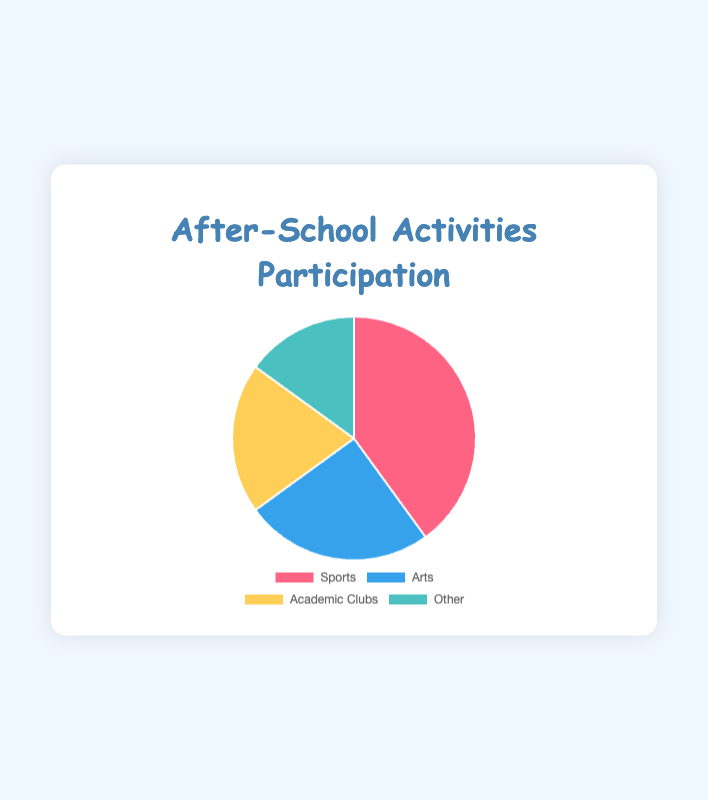Which activity has the highest participation percentage? The pie chart shows the participation percentages for different activities. By looking at the chart, we see that "Sports" has the largest segment.
Answer: Sports Which activity type has the smallest participation percentage? The pie chart segments represent different activity types, each labeled with its percentage. The smallest segment corresponds to "Other," indicating it has the lowest participation.
Answer: Other What is the combined participation percentage for Arts and Academic Clubs? To find the combined percentage, sum up the participation percentages of "Arts" and "Academic Clubs". Arts have 25% and Academic Clubs have 20%. 25% + 20% = 45%
Answer: 45% How much larger is the participation in Sports compared to Other activities? Calculate the difference between the Sports participation percentage (40%) and the Other activities participation percentage (15%). 40% - 15% = 25%
Answer: 25% If you combine the participation percentages of Academic Clubs and Other activities, does it exceed the participation in Arts? First, find the combined percentage of Academic Clubs (20%) and Other activities (15%) which equals 35%. Then compare this sum to the Arts participation percentage (25%). Since 35% > 25%, it exceeds the participation in Arts.
Answer: Yes What percentage of students participate in non-Sports activities? To find this, sum the percentages of all activities except Sports. Arts is 25%, Academic Clubs is 20%, and Other is 15%. 25% + 20% + 15% = 60%
Answer: 60% Which two activity types have the closest participation percentages? Compare the percentages for Arts (25%), Academic Clubs (20%), and Other (15%). The closest percentages are between Academic Clubs and Other, with a 5% difference.
Answer: Academic Clubs and Other What is the difference between the total percentage of students participating in Academic-focused and non-Academic-focused activities? Summing the academic-related (Academic Clubs) gives 20%. For non-academic, sum of Sports, Arts, and Other gives us 40% + 25% + 15% = 80%. The difference is 80% - 20% = 60%.
Answer: 60% 